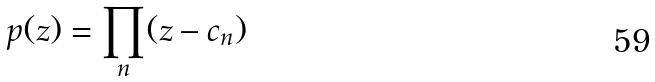<formula> <loc_0><loc_0><loc_500><loc_500>p ( z ) = \prod _ { n } ( z - c _ { n } )</formula> 